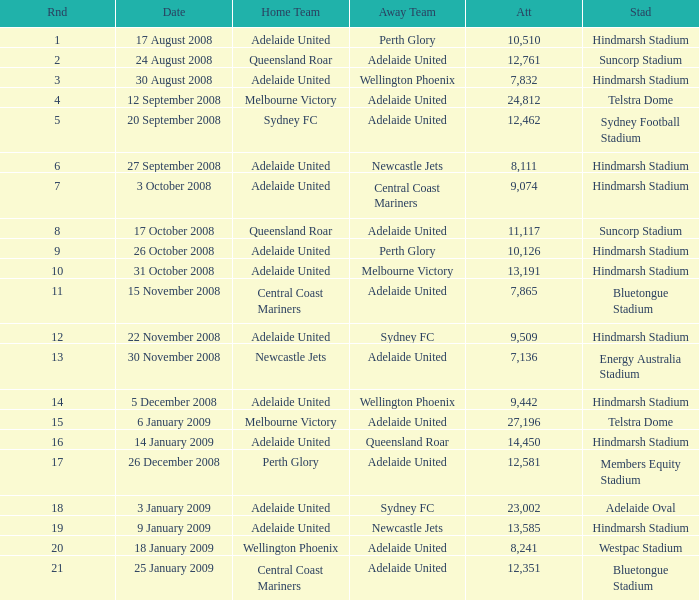What is the least round for the game played at Members Equity Stadium in from of 12,581 people? None. Could you parse the entire table? {'header': ['Rnd', 'Date', 'Home Team', 'Away Team', 'Att', 'Stad'], 'rows': [['1', '17 August 2008', 'Adelaide United', 'Perth Glory', '10,510', 'Hindmarsh Stadium'], ['2', '24 August 2008', 'Queensland Roar', 'Adelaide United', '12,761', 'Suncorp Stadium'], ['3', '30 August 2008', 'Adelaide United', 'Wellington Phoenix', '7,832', 'Hindmarsh Stadium'], ['4', '12 September 2008', 'Melbourne Victory', 'Adelaide United', '24,812', 'Telstra Dome'], ['5', '20 September 2008', 'Sydney FC', 'Adelaide United', '12,462', 'Sydney Football Stadium'], ['6', '27 September 2008', 'Adelaide United', 'Newcastle Jets', '8,111', 'Hindmarsh Stadium'], ['7', '3 October 2008', 'Adelaide United', 'Central Coast Mariners', '9,074', 'Hindmarsh Stadium'], ['8', '17 October 2008', 'Queensland Roar', 'Adelaide United', '11,117', 'Suncorp Stadium'], ['9', '26 October 2008', 'Adelaide United', 'Perth Glory', '10,126', 'Hindmarsh Stadium'], ['10', '31 October 2008', 'Adelaide United', 'Melbourne Victory', '13,191', 'Hindmarsh Stadium'], ['11', '15 November 2008', 'Central Coast Mariners', 'Adelaide United', '7,865', 'Bluetongue Stadium'], ['12', '22 November 2008', 'Adelaide United', 'Sydney FC', '9,509', 'Hindmarsh Stadium'], ['13', '30 November 2008', 'Newcastle Jets', 'Adelaide United', '7,136', 'Energy Australia Stadium'], ['14', '5 December 2008', 'Adelaide United', 'Wellington Phoenix', '9,442', 'Hindmarsh Stadium'], ['15', '6 January 2009', 'Melbourne Victory', 'Adelaide United', '27,196', 'Telstra Dome'], ['16', '14 January 2009', 'Adelaide United', 'Queensland Roar', '14,450', 'Hindmarsh Stadium'], ['17', '26 December 2008', 'Perth Glory', 'Adelaide United', '12,581', 'Members Equity Stadium'], ['18', '3 January 2009', 'Adelaide United', 'Sydney FC', '23,002', 'Adelaide Oval'], ['19', '9 January 2009', 'Adelaide United', 'Newcastle Jets', '13,585', 'Hindmarsh Stadium'], ['20', '18 January 2009', 'Wellington Phoenix', 'Adelaide United', '8,241', 'Westpac Stadium'], ['21', '25 January 2009', 'Central Coast Mariners', 'Adelaide United', '12,351', 'Bluetongue Stadium']]} 